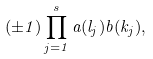<formula> <loc_0><loc_0><loc_500><loc_500>( \pm 1 ) \prod ^ { s } _ { j = 1 } a ( l _ { j } ) b ( k _ { j } ) ,</formula> 